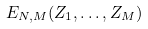Convert formula to latex. <formula><loc_0><loc_0><loc_500><loc_500>E _ { N , M } ( Z _ { 1 } , \dots , Z _ { M } )</formula> 